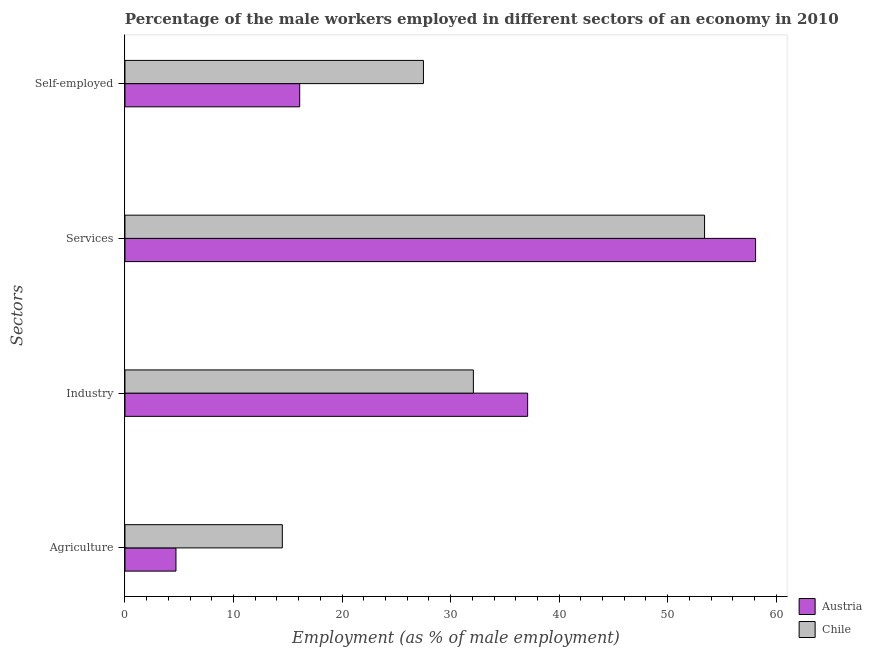Are the number of bars per tick equal to the number of legend labels?
Your response must be concise. Yes. Are the number of bars on each tick of the Y-axis equal?
Give a very brief answer. Yes. How many bars are there on the 3rd tick from the top?
Make the answer very short. 2. How many bars are there on the 2nd tick from the bottom?
Your answer should be compact. 2. What is the label of the 2nd group of bars from the top?
Keep it short and to the point. Services. What is the percentage of male workers in industry in Chile?
Offer a terse response. 32.1. Across all countries, what is the minimum percentage of male workers in services?
Give a very brief answer. 53.4. In which country was the percentage of male workers in industry minimum?
Provide a short and direct response. Chile. What is the total percentage of male workers in industry in the graph?
Offer a very short reply. 69.2. What is the difference between the percentage of male workers in industry in Chile and that in Austria?
Provide a succinct answer. -5. What is the difference between the percentage of male workers in industry in Austria and the percentage of self employed male workers in Chile?
Offer a terse response. 9.6. What is the average percentage of self employed male workers per country?
Offer a very short reply. 21.8. What is the difference between the percentage of male workers in services and percentage of self employed male workers in Austria?
Make the answer very short. 42. In how many countries, is the percentage of male workers in services greater than 6 %?
Your response must be concise. 2. What is the ratio of the percentage of male workers in industry in Chile to that in Austria?
Keep it short and to the point. 0.87. Is the difference between the percentage of self employed male workers in Austria and Chile greater than the difference between the percentage of male workers in industry in Austria and Chile?
Give a very brief answer. No. What is the difference between the highest and the second highest percentage of male workers in services?
Make the answer very short. 4.7. What is the difference between the highest and the lowest percentage of male workers in industry?
Offer a very short reply. 5. Is it the case that in every country, the sum of the percentage of male workers in services and percentage of male workers in agriculture is greater than the sum of percentage of male workers in industry and percentage of self employed male workers?
Ensure brevity in your answer.  No. What does the 1st bar from the top in Agriculture represents?
Your answer should be compact. Chile. Are all the bars in the graph horizontal?
Make the answer very short. Yes. How many countries are there in the graph?
Make the answer very short. 2. Are the values on the major ticks of X-axis written in scientific E-notation?
Offer a very short reply. No. Where does the legend appear in the graph?
Provide a succinct answer. Bottom right. How many legend labels are there?
Your response must be concise. 2. How are the legend labels stacked?
Keep it short and to the point. Vertical. What is the title of the graph?
Your answer should be compact. Percentage of the male workers employed in different sectors of an economy in 2010. What is the label or title of the X-axis?
Provide a succinct answer. Employment (as % of male employment). What is the label or title of the Y-axis?
Ensure brevity in your answer.  Sectors. What is the Employment (as % of male employment) of Austria in Agriculture?
Provide a succinct answer. 4.7. What is the Employment (as % of male employment) of Chile in Agriculture?
Your answer should be very brief. 14.5. What is the Employment (as % of male employment) of Austria in Industry?
Provide a succinct answer. 37.1. What is the Employment (as % of male employment) in Chile in Industry?
Your answer should be compact. 32.1. What is the Employment (as % of male employment) of Austria in Services?
Your response must be concise. 58.1. What is the Employment (as % of male employment) of Chile in Services?
Give a very brief answer. 53.4. What is the Employment (as % of male employment) of Austria in Self-employed?
Your response must be concise. 16.1. What is the Employment (as % of male employment) in Chile in Self-employed?
Provide a short and direct response. 27.5. Across all Sectors, what is the maximum Employment (as % of male employment) in Austria?
Your answer should be very brief. 58.1. Across all Sectors, what is the maximum Employment (as % of male employment) in Chile?
Your response must be concise. 53.4. Across all Sectors, what is the minimum Employment (as % of male employment) of Austria?
Your response must be concise. 4.7. What is the total Employment (as % of male employment) in Austria in the graph?
Make the answer very short. 116. What is the total Employment (as % of male employment) in Chile in the graph?
Your answer should be very brief. 127.5. What is the difference between the Employment (as % of male employment) in Austria in Agriculture and that in Industry?
Your answer should be compact. -32.4. What is the difference between the Employment (as % of male employment) of Chile in Agriculture and that in Industry?
Give a very brief answer. -17.6. What is the difference between the Employment (as % of male employment) in Austria in Agriculture and that in Services?
Ensure brevity in your answer.  -53.4. What is the difference between the Employment (as % of male employment) in Chile in Agriculture and that in Services?
Provide a short and direct response. -38.9. What is the difference between the Employment (as % of male employment) in Austria in Agriculture and that in Self-employed?
Provide a succinct answer. -11.4. What is the difference between the Employment (as % of male employment) of Chile in Agriculture and that in Self-employed?
Give a very brief answer. -13. What is the difference between the Employment (as % of male employment) in Chile in Industry and that in Services?
Your answer should be compact. -21.3. What is the difference between the Employment (as % of male employment) of Austria in Industry and that in Self-employed?
Offer a terse response. 21. What is the difference between the Employment (as % of male employment) in Chile in Services and that in Self-employed?
Your answer should be very brief. 25.9. What is the difference between the Employment (as % of male employment) of Austria in Agriculture and the Employment (as % of male employment) of Chile in Industry?
Your response must be concise. -27.4. What is the difference between the Employment (as % of male employment) of Austria in Agriculture and the Employment (as % of male employment) of Chile in Services?
Your answer should be very brief. -48.7. What is the difference between the Employment (as % of male employment) in Austria in Agriculture and the Employment (as % of male employment) in Chile in Self-employed?
Offer a very short reply. -22.8. What is the difference between the Employment (as % of male employment) of Austria in Industry and the Employment (as % of male employment) of Chile in Services?
Provide a short and direct response. -16.3. What is the difference between the Employment (as % of male employment) in Austria in Industry and the Employment (as % of male employment) in Chile in Self-employed?
Ensure brevity in your answer.  9.6. What is the difference between the Employment (as % of male employment) in Austria in Services and the Employment (as % of male employment) in Chile in Self-employed?
Ensure brevity in your answer.  30.6. What is the average Employment (as % of male employment) in Austria per Sectors?
Provide a succinct answer. 29. What is the average Employment (as % of male employment) in Chile per Sectors?
Provide a short and direct response. 31.88. What is the difference between the Employment (as % of male employment) in Austria and Employment (as % of male employment) in Chile in Industry?
Ensure brevity in your answer.  5. What is the difference between the Employment (as % of male employment) of Austria and Employment (as % of male employment) of Chile in Self-employed?
Your answer should be very brief. -11.4. What is the ratio of the Employment (as % of male employment) in Austria in Agriculture to that in Industry?
Your response must be concise. 0.13. What is the ratio of the Employment (as % of male employment) in Chile in Agriculture to that in Industry?
Offer a terse response. 0.45. What is the ratio of the Employment (as % of male employment) in Austria in Agriculture to that in Services?
Ensure brevity in your answer.  0.08. What is the ratio of the Employment (as % of male employment) of Chile in Agriculture to that in Services?
Your answer should be very brief. 0.27. What is the ratio of the Employment (as % of male employment) in Austria in Agriculture to that in Self-employed?
Your answer should be compact. 0.29. What is the ratio of the Employment (as % of male employment) in Chile in Agriculture to that in Self-employed?
Give a very brief answer. 0.53. What is the ratio of the Employment (as % of male employment) of Austria in Industry to that in Services?
Your answer should be very brief. 0.64. What is the ratio of the Employment (as % of male employment) in Chile in Industry to that in Services?
Ensure brevity in your answer.  0.6. What is the ratio of the Employment (as % of male employment) in Austria in Industry to that in Self-employed?
Make the answer very short. 2.3. What is the ratio of the Employment (as % of male employment) of Chile in Industry to that in Self-employed?
Provide a short and direct response. 1.17. What is the ratio of the Employment (as % of male employment) in Austria in Services to that in Self-employed?
Offer a very short reply. 3.61. What is the ratio of the Employment (as % of male employment) in Chile in Services to that in Self-employed?
Offer a terse response. 1.94. What is the difference between the highest and the second highest Employment (as % of male employment) of Chile?
Ensure brevity in your answer.  21.3. What is the difference between the highest and the lowest Employment (as % of male employment) in Austria?
Make the answer very short. 53.4. What is the difference between the highest and the lowest Employment (as % of male employment) of Chile?
Your answer should be very brief. 38.9. 